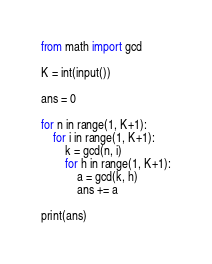<code> <loc_0><loc_0><loc_500><loc_500><_Python_>from math import gcd

K = int(input())

ans = 0

for n in range(1, K+1):
    for i in range(1, K+1):
        k = gcd(n, i)
        for h in range(1, K+1):
            a = gcd(k, h)
            ans += a
            
print(ans)</code> 